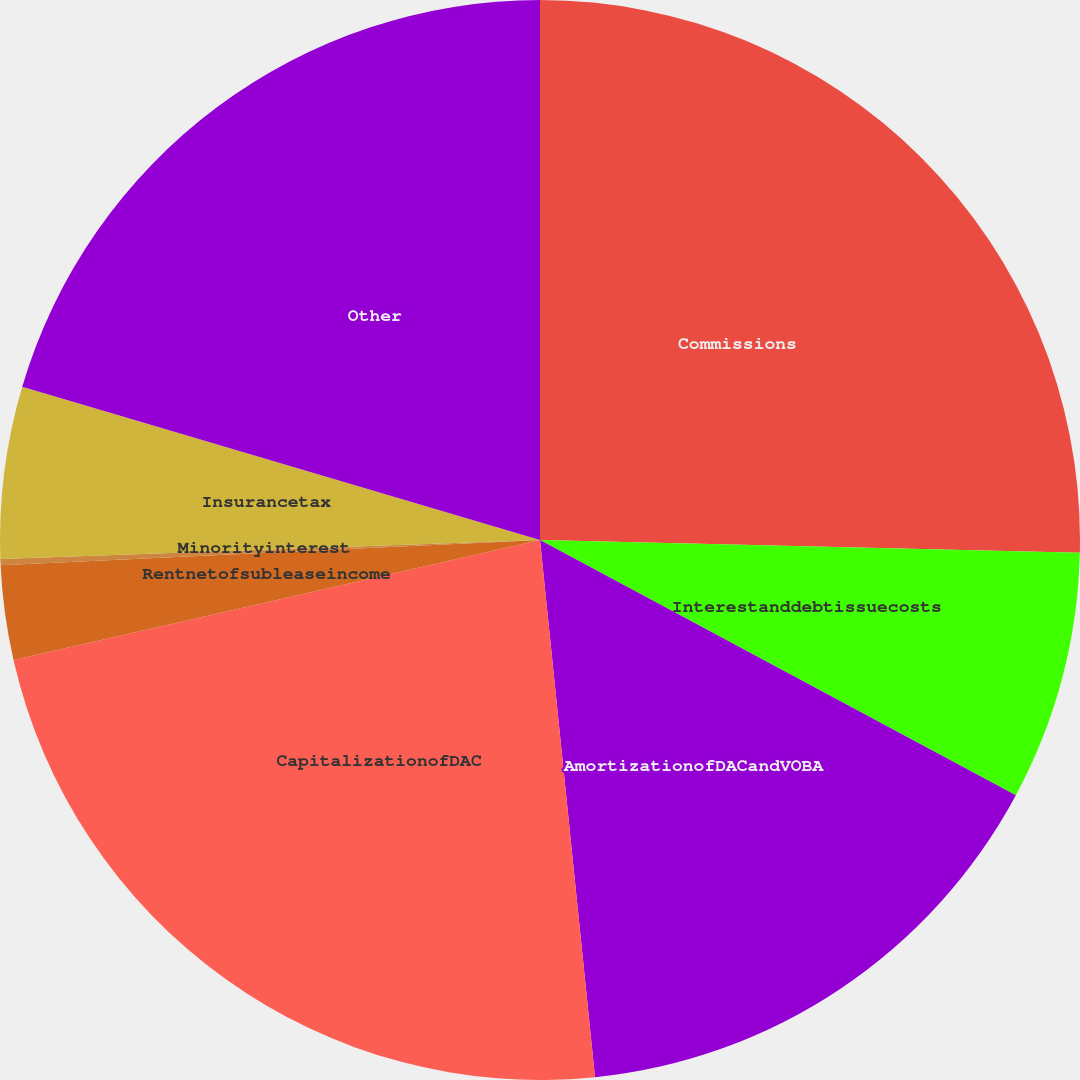Convert chart to OTSL. <chart><loc_0><loc_0><loc_500><loc_500><pie_chart><fcel>Commissions<fcel>Interestanddebtissuecosts<fcel>AmortizationofDACandVOBA<fcel>CapitalizationofDAC<fcel>Rentnetofsubleaseincome<fcel>Minorityinterest<fcel>Insurancetax<fcel>Other<nl><fcel>25.38%<fcel>7.46%<fcel>15.54%<fcel>23.06%<fcel>2.82%<fcel>0.19%<fcel>5.14%<fcel>20.42%<nl></chart> 